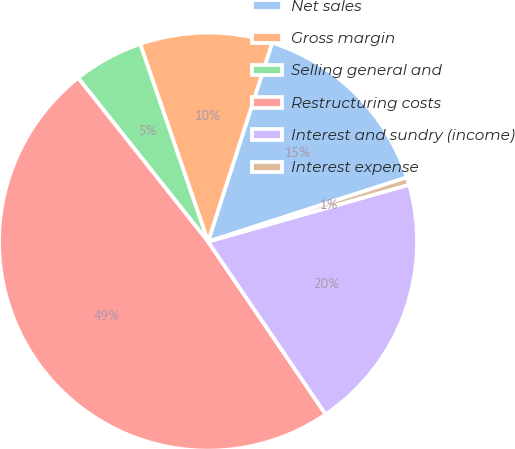Convert chart. <chart><loc_0><loc_0><loc_500><loc_500><pie_chart><fcel>Net sales<fcel>Gross margin<fcel>Selling general and<fcel>Restructuring costs<fcel>Interest and sundry (income)<fcel>Interest expense<nl><fcel>15.06%<fcel>10.23%<fcel>5.41%<fcel>48.84%<fcel>19.88%<fcel>0.58%<nl></chart> 